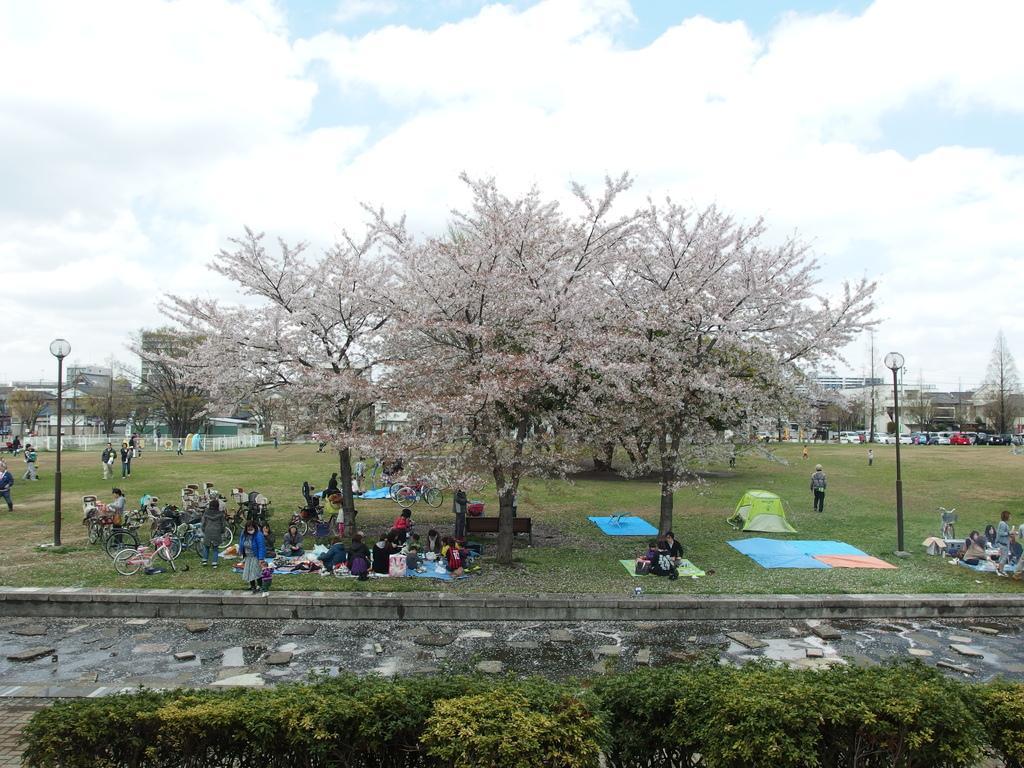In one or two sentences, can you explain what this image depicts? In this image in the center there are a group of people some of them are sitting and some of them are standing and some of them or walking. At the bottom there is a walkway and some plants, in the background there are some buildings, trees, vehicles, poles, and lights, at the top of the image there is sky. 